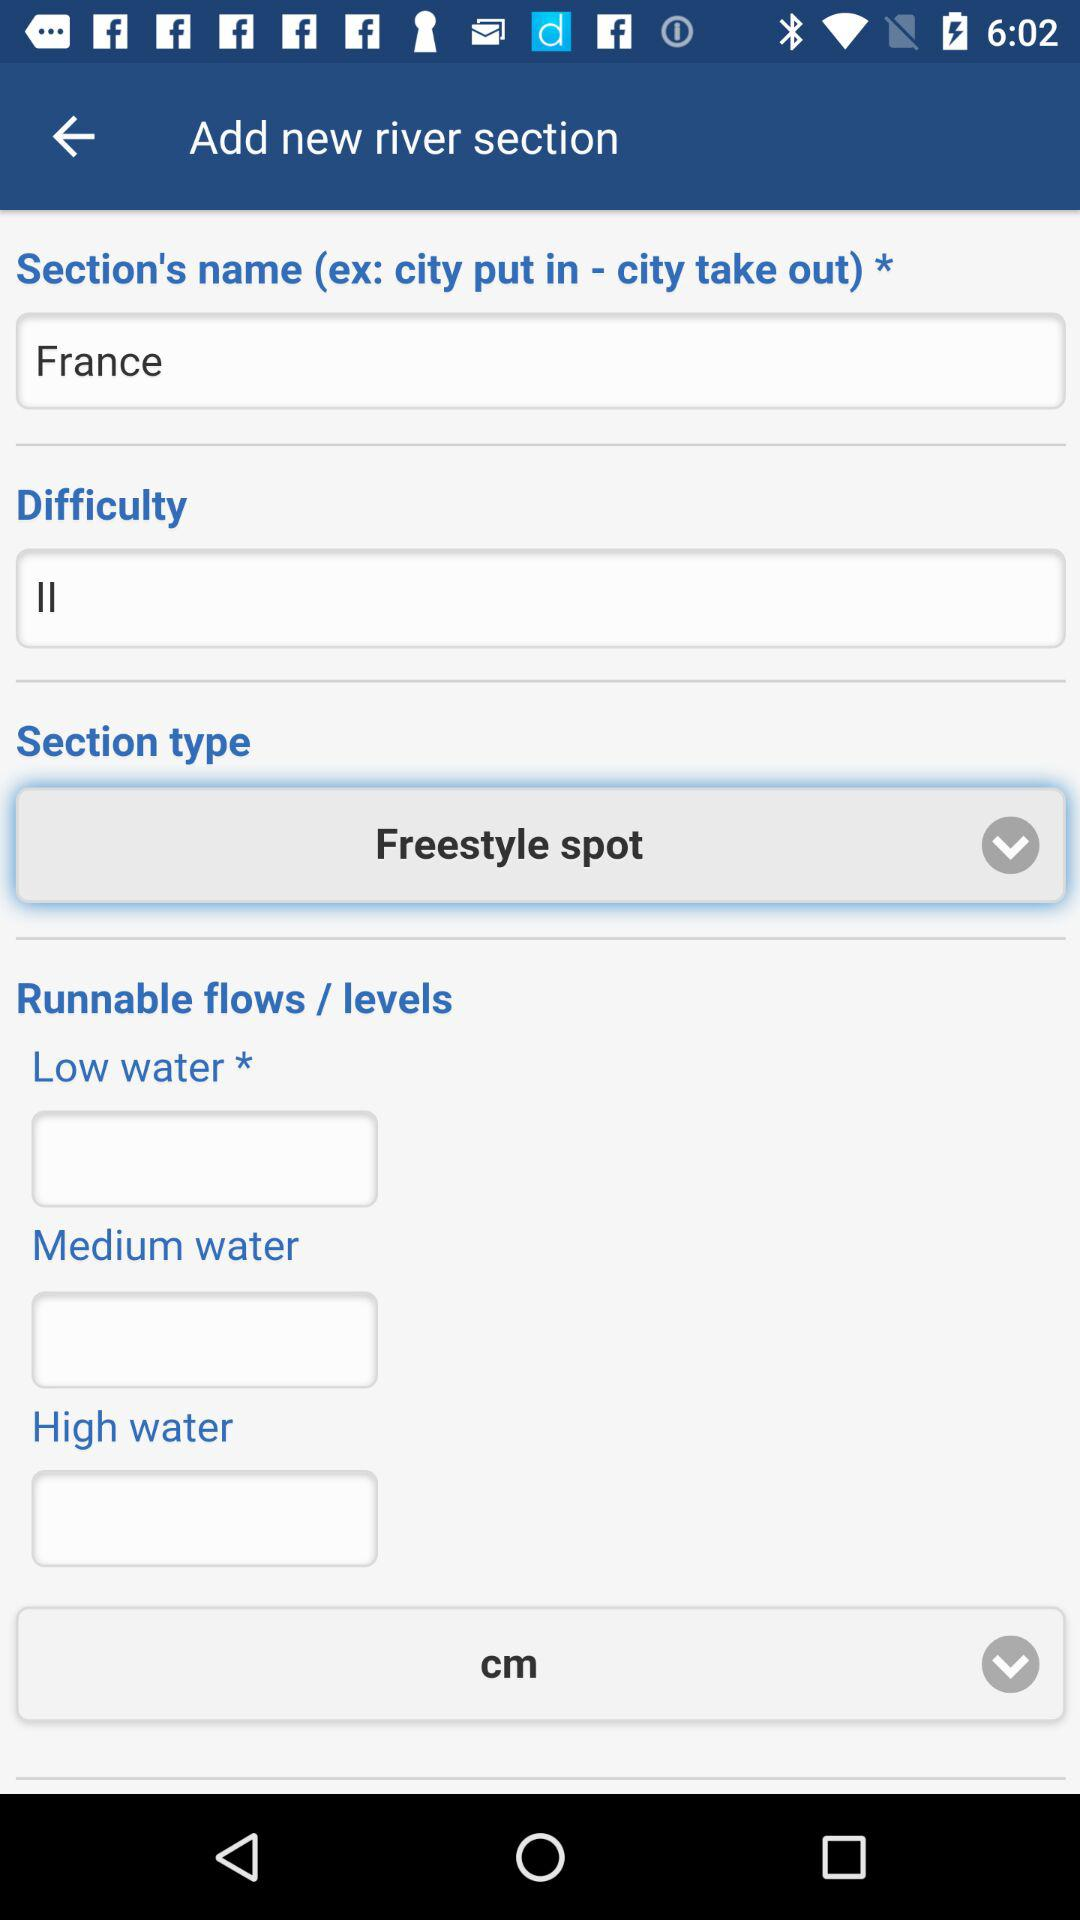What is the measuring unit of the "Runnable flows / levels"? The measuring unit is "cm". 